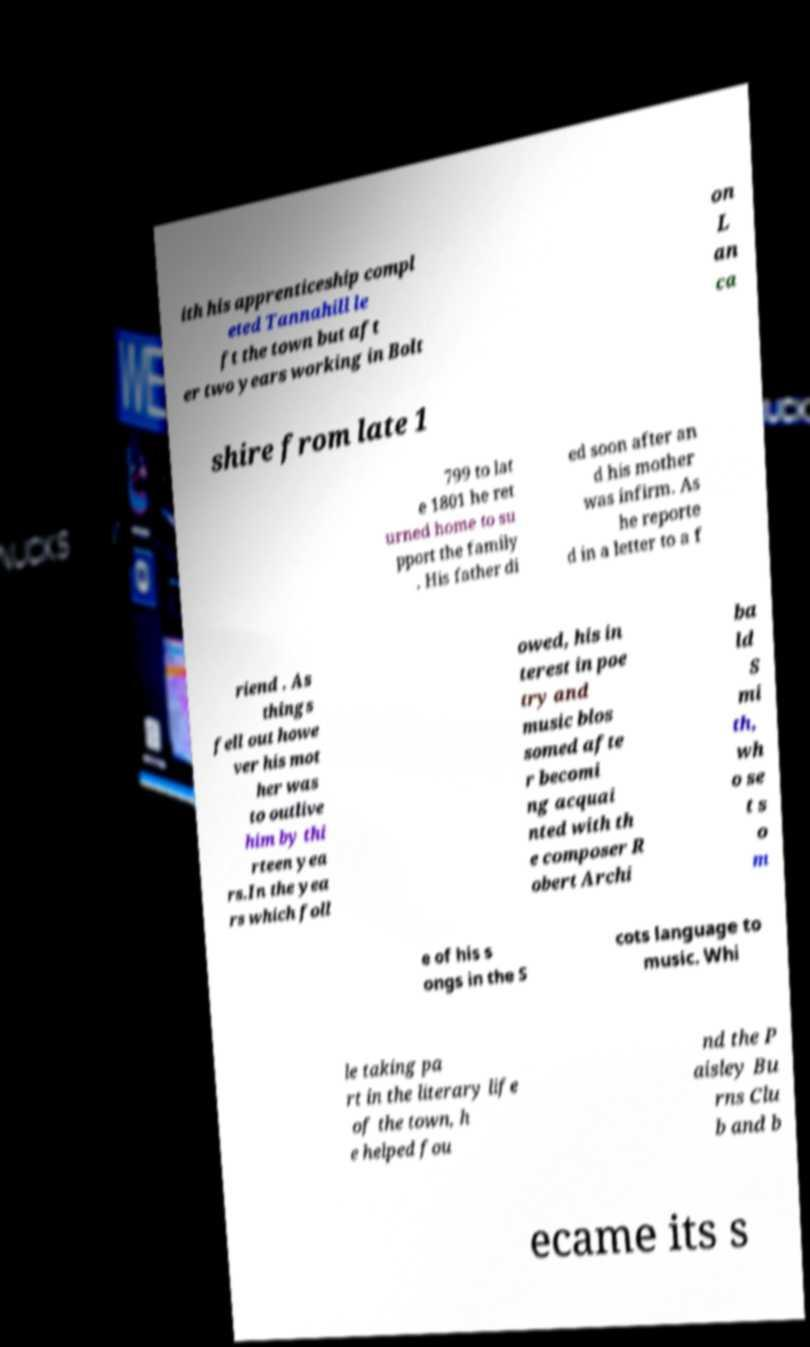Can you accurately transcribe the text from the provided image for me? ith his apprenticeship compl eted Tannahill le ft the town but aft er two years working in Bolt on L an ca shire from late 1 799 to lat e 1801 he ret urned home to su pport the family . His father di ed soon after an d his mother was infirm. As he reporte d in a letter to a f riend . As things fell out howe ver his mot her was to outlive him by thi rteen yea rs.In the yea rs which foll owed, his in terest in poe try and music blos somed afte r becomi ng acquai nted with th e composer R obert Archi ba ld S mi th, wh o se t s o m e of his s ongs in the S cots language to music. Whi le taking pa rt in the literary life of the town, h e helped fou nd the P aisley Bu rns Clu b and b ecame its s 